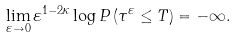<formula> <loc_0><loc_0><loc_500><loc_500>\lim _ { \varepsilon \to 0 } \varepsilon ^ { 1 - 2 \kappa } \log P \left ( \tau ^ { \varepsilon } \leq T \right ) = - \infty .</formula> 